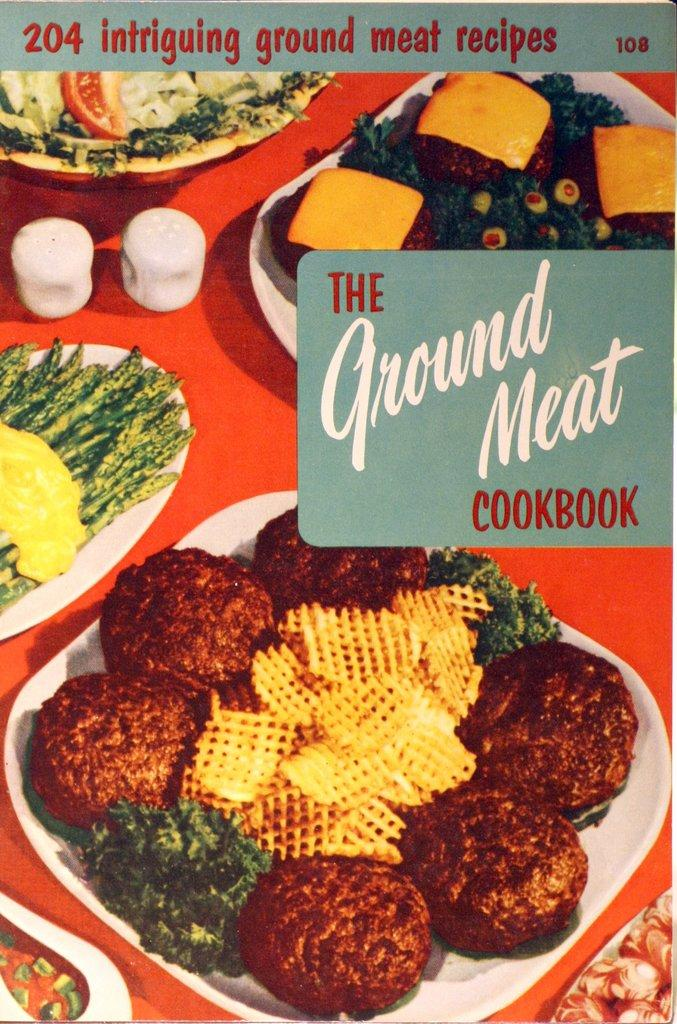What type of objects are present on the surface in the image? There are food items on plates in the image. What color is the surface on which the plates are placed? The surface is red in color. Is there any text or writing on the surface? Yes, there is writing on the surface. Can you tell me how many slaves are depicted in the image? There are no slaves present in the image; it features food items on plates. What type of activity is the father performing in the image? There is no father or any activity involving a father depicted in the image. 